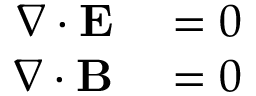Convert formula to latex. <formula><loc_0><loc_0><loc_500><loc_500>\begin{array} { r l } { \nabla \cdot E } & = 0 } \\ { \nabla \cdot B } & = 0 } \end{array}</formula> 